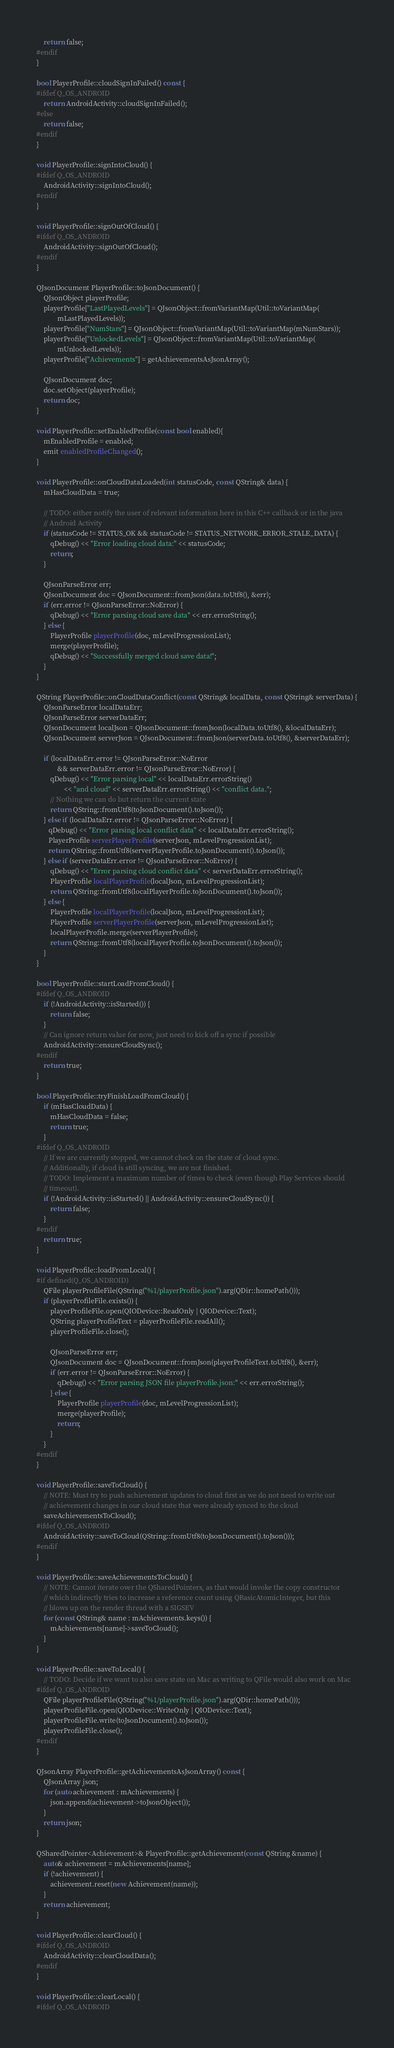Convert code to text. <code><loc_0><loc_0><loc_500><loc_500><_C++_>    return false;
#endif
}

bool PlayerProfile::cloudSignInFailed() const {
#ifdef Q_OS_ANDROID
    return AndroidActivity::cloudSignInFailed();
#else
    return false;
#endif
}

void PlayerProfile::signIntoCloud() {
#ifdef Q_OS_ANDROID
    AndroidActivity::signIntoCloud();
#endif
}

void PlayerProfile::signOutOfCloud() {
#ifdef Q_OS_ANDROID
    AndroidActivity::signOutOfCloud();
#endif
}

QJsonDocument PlayerProfile::toJsonDocument() {
    QJsonObject playerProfile;
    playerProfile["LastPlayedLevels"] = QJsonObject::fromVariantMap(Util::toVariantMap(
            mLastPlayedLevels));
    playerProfile["NumStars"] = QJsonObject::fromVariantMap(Util::toVariantMap(mNumStars));
    playerProfile["UnlockedLevels"] = QJsonObject::fromVariantMap(Util::toVariantMap(
            mUnlockedLevels));
    playerProfile["Achievements"] = getAchievementsAsJsonArray();

    QJsonDocument doc;
    doc.setObject(playerProfile);
    return doc;
}

void PlayerProfile::setEnabledProfile(const bool enabled){
    mEnabledProfile = enabled;
    emit enabledProfileChanged();
}

void PlayerProfile::onCloudDataLoaded(int statusCode, const QString& data) {
    mHasCloudData = true;

    // TODO: either notify the user of relevant information here in this C++ callback or in the java
    // Android Activity
    if (statusCode != STATUS_OK && statusCode != STATUS_NETWORK_ERROR_STALE_DATA) {
        qDebug() << "Error loading cloud data:" << statusCode;
        return;
    }

    QJsonParseError err;
    QJsonDocument doc = QJsonDocument::fromJson(data.toUtf8(), &err);
    if (err.error != QJsonParseError::NoError) {
        qDebug() << "Error parsing cloud save data" << err.errorString();
    } else {
        PlayerProfile playerProfile(doc, mLevelProgressionList);
        merge(playerProfile);
        qDebug() << "Successfully merged cloud save data!";
    }
}

QString PlayerProfile::onCloudDataConflict(const QString& localData, const QString& serverData) {
    QJsonParseError localDataErr;
    QJsonParseError serverDataErr;
    QJsonDocument localJson = QJsonDocument::fromJson(localData.toUtf8(), &localDataErr);
    QJsonDocument serverJson = QJsonDocument::fromJson(serverData.toUtf8(), &serverDataErr);

    if (localDataErr.error != QJsonParseError::NoError
            && serverDataErr.error != QJsonParseError::NoError) {
        qDebug() << "Error parsing local" << localDataErr.errorString()
                << "and cloud" << serverDataErr.errorString() << "conflict data.";
        // Nothing we can do but return the current state
        return QString::fromUtf8(toJsonDocument().toJson());
    } else if (localDataErr.error != QJsonParseError::NoError) {
       qDebug() << "Error parsing local conflict data" << localDataErr.errorString();
       PlayerProfile serverPlayerProfile(serverJson, mLevelProgressionList);
       return QString::fromUtf8(serverPlayerProfile.toJsonDocument().toJson());
    } else if (serverDataErr.error != QJsonParseError::NoError) {
        qDebug() << "Error parsing cloud conflict data" << serverDataErr.errorString();
        PlayerProfile localPlayerProfile(localJson, mLevelProgressionList);
        return QString::fromUtf8(localPlayerProfile.toJsonDocument().toJson());
    } else {
        PlayerProfile localPlayerProfile(localJson, mLevelProgressionList);
        PlayerProfile serverPlayerProfile(serverJson, mLevelProgressionList);
        localPlayerProfile.merge(serverPlayerProfile);
        return QString::fromUtf8(localPlayerProfile.toJsonDocument().toJson());
    }
}

bool PlayerProfile::startLoadFromCloud() {
#ifdef Q_OS_ANDROID
    if (!AndroidActivity::isStarted()) {
        return false;
    }
    // Can ignore return value for now, just need to kick off a sync if possible
    AndroidActivity::ensureCloudSync();
#endif
    return true;
}

bool PlayerProfile::tryFinishLoadFromCloud() {
    if (mHasCloudData) {
        mHasCloudData = false;
        return true;
    }
#ifdef Q_OS_ANDROID
    // If we are currently stopped, we cannot check on the state of cloud sync.
    // Additionally, if cloud is still syncing, we are not finished.
    // TODO: Implement a maximum number of times to check (even though Play Services should
    // timeout).
    if (!AndroidActivity::isStarted() || AndroidActivity::ensureCloudSync()) {
        return false;
    }
#endif
    return true;
}

void PlayerProfile::loadFromLocal() {
#if defined(Q_OS_ANDROID)
    QFile playerProfileFile(QString("%1/playerProfile.json").arg(QDir::homePath()));
    if (playerProfileFile.exists()) {
        playerProfileFile.open(QIODevice::ReadOnly | QIODevice::Text);
        QString playerProfileText = playerProfileFile.readAll();
        playerProfileFile.close();

        QJsonParseError err;
        QJsonDocument doc = QJsonDocument::fromJson(playerProfileText.toUtf8(), &err);
        if (err.error != QJsonParseError::NoError) {
            qDebug() << "Error parsing JSON file playerProfile.json:" << err.errorString();
        } else {
            PlayerProfile playerProfile(doc, mLevelProgressionList);
            merge(playerProfile);
            return;
        }
    }
#endif
}

void PlayerProfile::saveToCloud() {
    // NOTE: Must try to push achievement updates to cloud first as we do not need to write out
    // achievement changes in our cloud state that were already synced to the cloud
    saveAchievementsToCloud();
#ifdef Q_OS_ANDROID
    AndroidActivity::saveToCloud(QString::fromUtf8(toJsonDocument().toJson()));
#endif
}

void PlayerProfile::saveAchievementsToCloud() {
    // NOTE: Cannot iterate over the QSharedPointers, as that would invoke the copy constructor
    // which indirectly tries to increase a reference count using QBasicAtomicInteger, but this
    // blows up on the render thread with a SIGSEV
    for (const QString& name : mAchievements.keys()) {
        mAchievements[name]->saveToCloud();
    }
}

void PlayerProfile::saveToLocal() {
    // TODO: Decide if we want to also save state on Mac as writing to QFile would also work on Mac
#ifdef Q_OS_ANDROID
    QFile playerProfileFile(QString("%1/playerProfile.json").arg(QDir::homePath()));
    playerProfileFile.open(QIODevice::WriteOnly | QIODevice::Text);
    playerProfileFile.write(toJsonDocument().toJson());
    playerProfileFile.close();
#endif
}

QJsonArray PlayerProfile::getAchievementsAsJsonArray() const {
    QJsonArray json;
    for (auto achievement : mAchievements) {
        json.append(achievement->toJsonObject());
    }
    return json;
}

QSharedPointer<Achievement>& PlayerProfile::getAchievement(const QString &name) {
    auto& achievement = mAchievements[name];
    if (!achievement) {
        achievement.reset(new Achievement(name));
    }
    return achievement;
}

void PlayerProfile::clearCloud() {
#ifdef Q_OS_ANDROID
    AndroidActivity::clearCloudData();
#endif
}

void PlayerProfile::clearLocal() {
#ifdef Q_OS_ANDROID</code> 